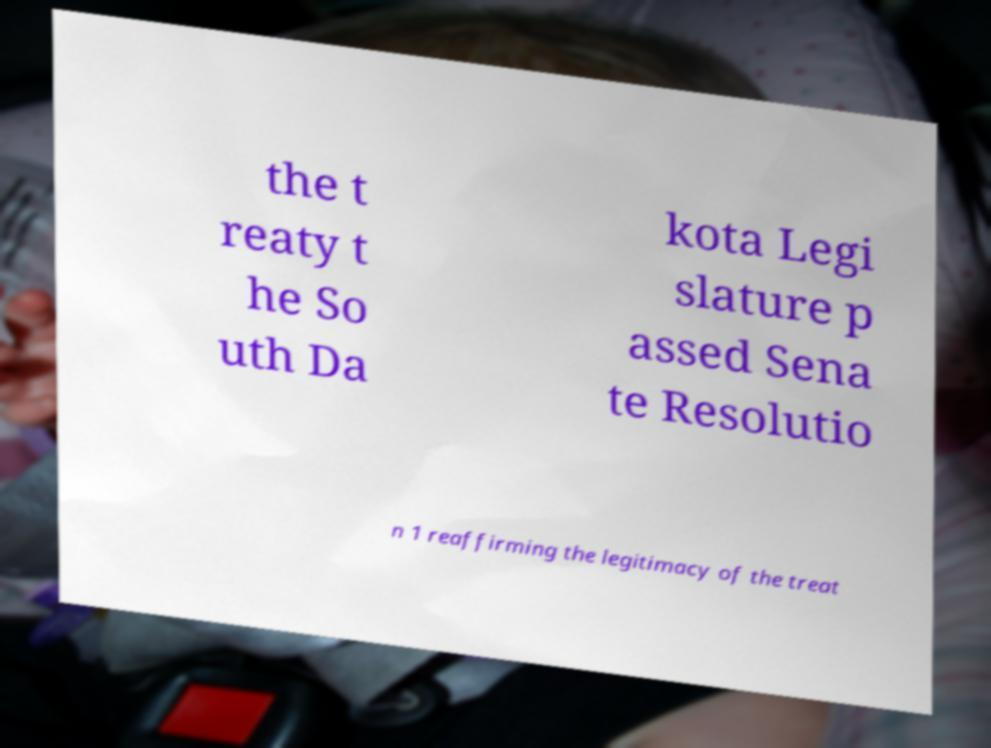I need the written content from this picture converted into text. Can you do that? the t reaty t he So uth Da kota Legi slature p assed Sena te Resolutio n 1 reaffirming the legitimacy of the treat 